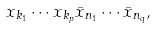<formula> <loc_0><loc_0><loc_500><loc_500>x _ { k _ { 1 } } \cdots x _ { k _ { p } } \bar { x } _ { n _ { 1 } } \cdots \bar { x } _ { n _ { q } } ,</formula> 